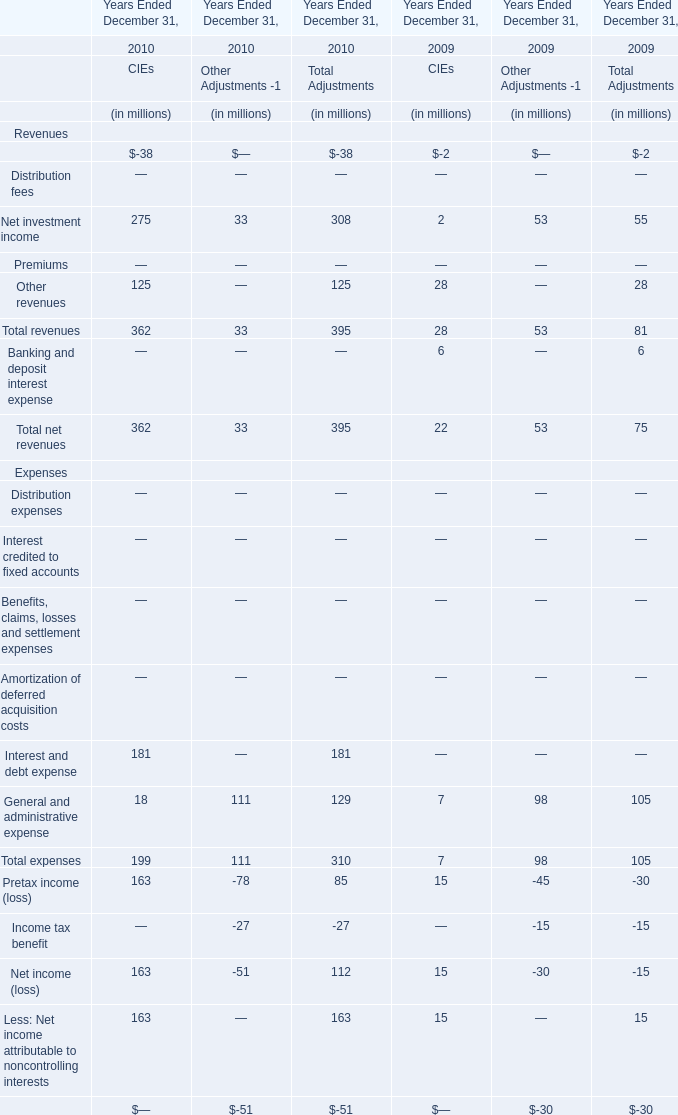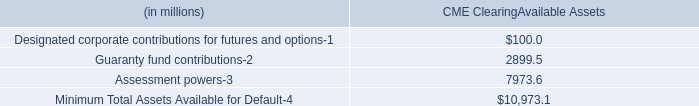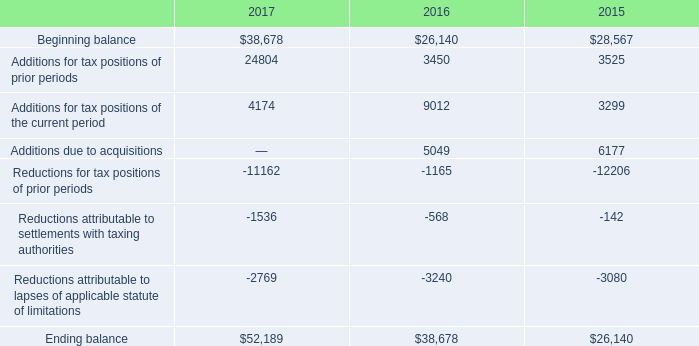Which year is Management and financial advice fees of CIEs the least? 
Answer: 2010. 